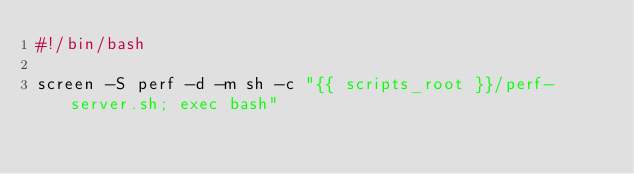Convert code to text. <code><loc_0><loc_0><loc_500><loc_500><_Bash_>#!/bin/bash

screen -S perf -d -m sh -c "{{ scripts_root }}/perf-server.sh; exec bash"
</code> 